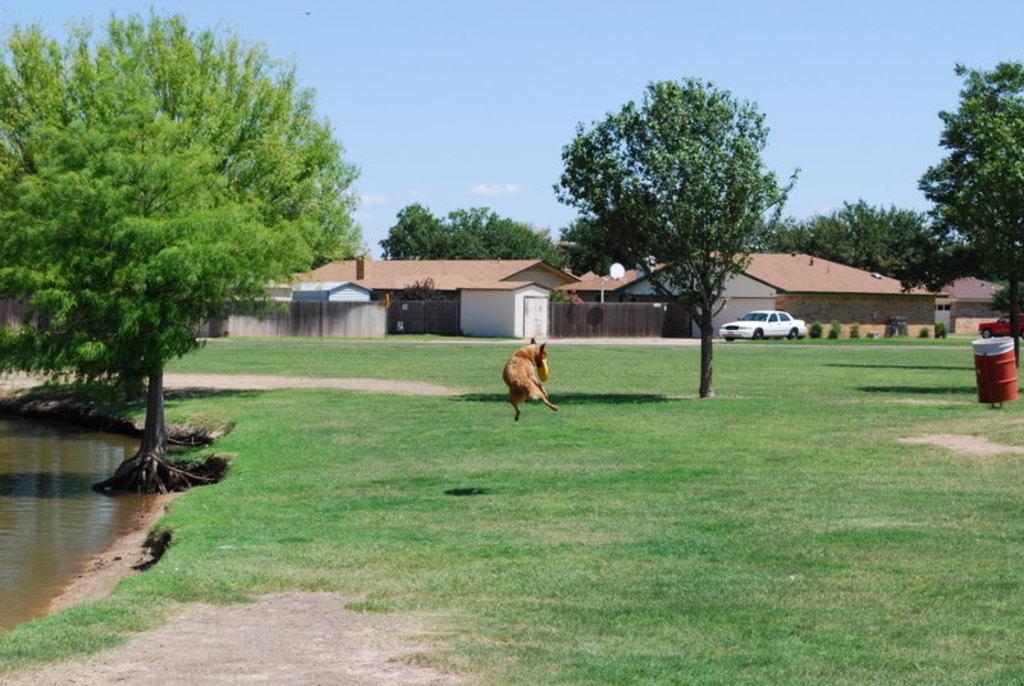Describe this image in one or two sentences. On the left side there is water. Near to that there are trees. On the ground there is grass. Also there is a tree. And there is a dog jumping and biting a disc. On the right side there is a barrel and a tree. In the background there are buildings with gate. Also there are cars. And there are trees and sky. 